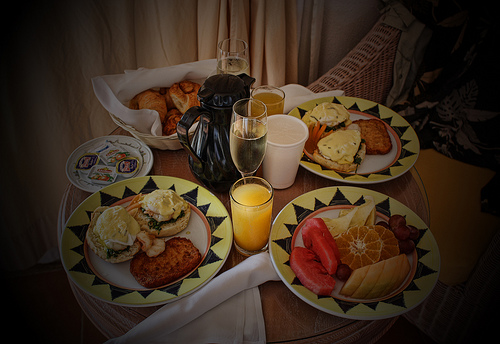<image>
Is there a food on the plate? No. The food is not positioned on the plate. They may be near each other, but the food is not supported by or resting on top of the plate. Where is the juice glass in relation to the wine glass? Is it to the left of the wine glass? No. The juice glass is not to the left of the wine glass. From this viewpoint, they have a different horizontal relationship. Is there a curtain behind the table? Yes. From this viewpoint, the curtain is positioned behind the table, with the table partially or fully occluding the curtain. 